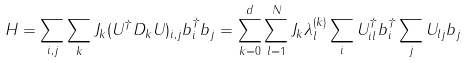Convert formula to latex. <formula><loc_0><loc_0><loc_500><loc_500>H = \sum _ { i , j } \sum _ { k } J _ { k } ( U ^ { \dag } D _ { k } U ) _ { i , j } b ^ { \dag } _ { i } b _ { j } = \sum _ { k = 0 } ^ { d } \sum _ { l = 1 } ^ { N } J _ { k } \lambda ^ { ( k ) } _ { l } \sum _ { i } U ^ { \dag } _ { i l } b ^ { \dag } _ { i } \sum _ { j } U _ { l j } b _ { j }</formula> 